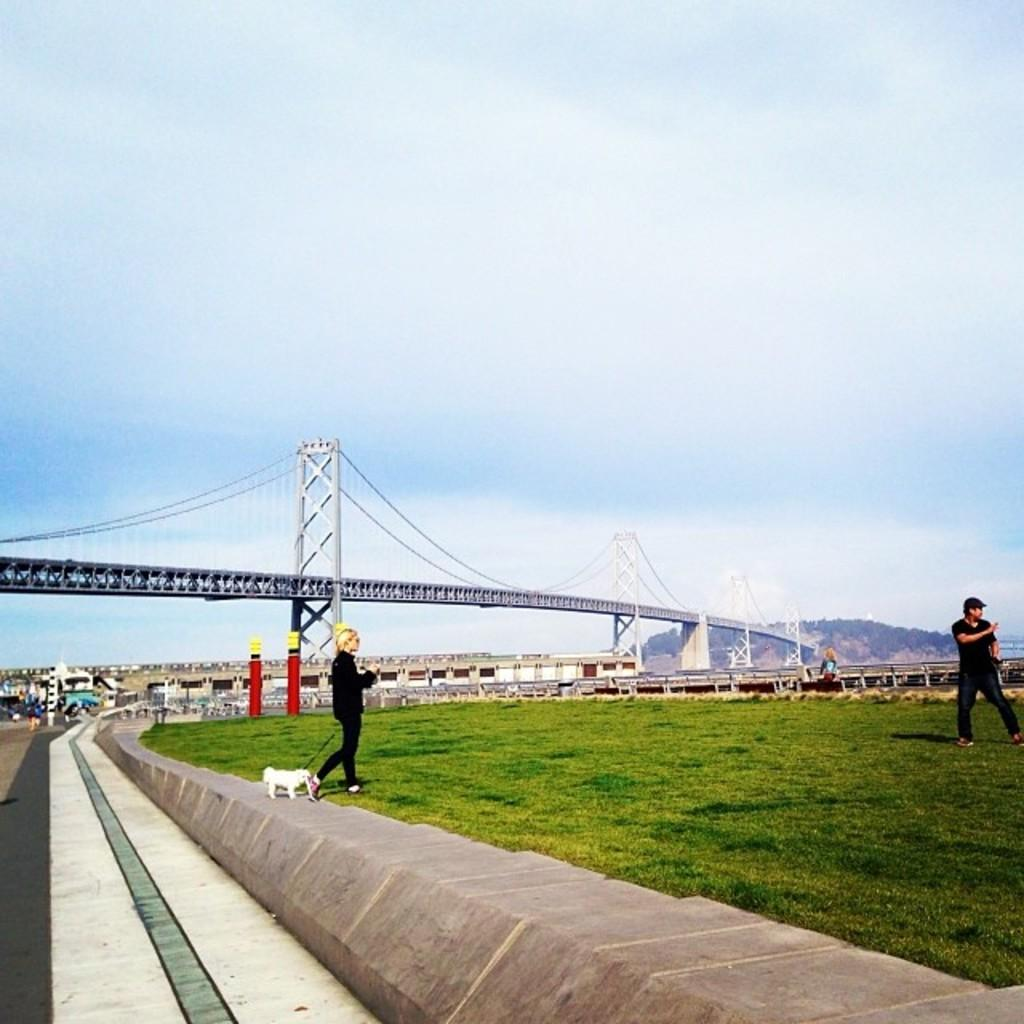What type of terrain is visible on the right side of the image? There is an open grass ground on the right side of the image. What animal can be seen on the grass ground? A dog is present on the grass ground. How many people are standing on the grass ground? Two persons are standing on the grass ground. What can be seen in the background of the image? There is a bridge and clouds visible in the background of the image. What part of the natural environment is visible in the background of the image? The sky is visible in the background of the image. What type of match is being played on the grass ground in the image? There is no match being played in the image; it features a dog and two persons standing on the grass ground. What season is depicted in the image, considering the presence of winter? The image does not depict any specific season, and there is no indication of winter in the image. 